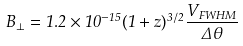Convert formula to latex. <formula><loc_0><loc_0><loc_500><loc_500>B _ { \bot } = 1 . 2 \times 1 0 ^ { - 1 5 } ( 1 + z ) ^ { 3 / 2 } \frac { V _ { F W H M } } { \Delta \theta }</formula> 